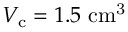Convert formula to latex. <formula><loc_0><loc_0><loc_500><loc_500>V _ { c } = 1 . 5 c m ^ { 3 }</formula> 